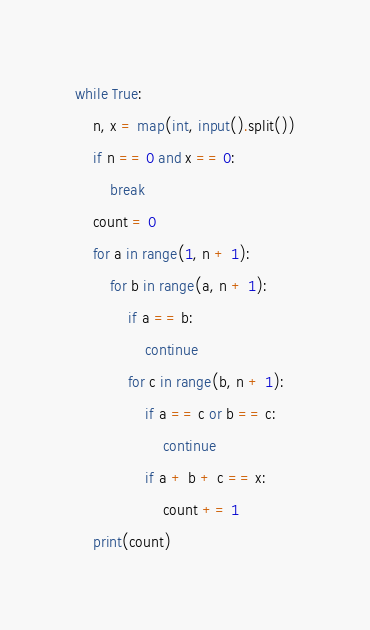<code> <loc_0><loc_0><loc_500><loc_500><_Python_>while True:
    n, x = map(int, input().split())
    if n == 0 and x == 0:
        break
    count = 0
    for a in range(1, n + 1):
        for b in range(a, n + 1):
            if a == b:
                continue
            for c in range(b, n + 1):
                if a == c or b == c:
                    continue
                if a + b + c == x:
                    count += 1
    print(count)

</code> 